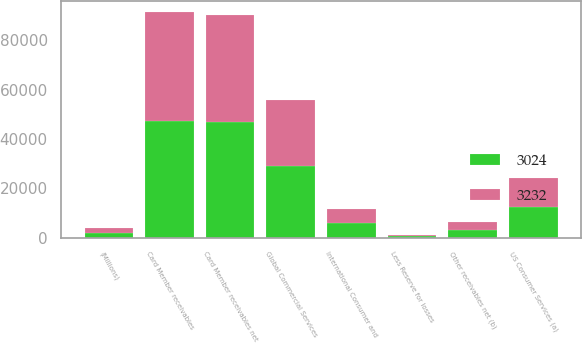Convert chart to OTSL. <chart><loc_0><loc_0><loc_500><loc_500><stacked_bar_chart><ecel><fcel>(Millions)<fcel>US Consumer Services (a)<fcel>International Consumer and<fcel>Global Commercial Services<fcel>Card Member receivables<fcel>Less Reserve for losses<fcel>Card Member receivables net<fcel>Other receivables net (b)<nl><fcel>3024<fcel>2016<fcel>12302<fcel>5966<fcel>29040<fcel>47308<fcel>467<fcel>46841<fcel>3232<nl><fcel>3232<fcel>2015<fcel>11807<fcel>5599<fcel>26727<fcel>44133<fcel>462<fcel>43671<fcel>3024<nl></chart> 